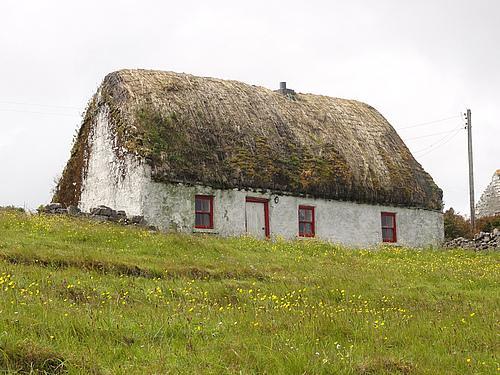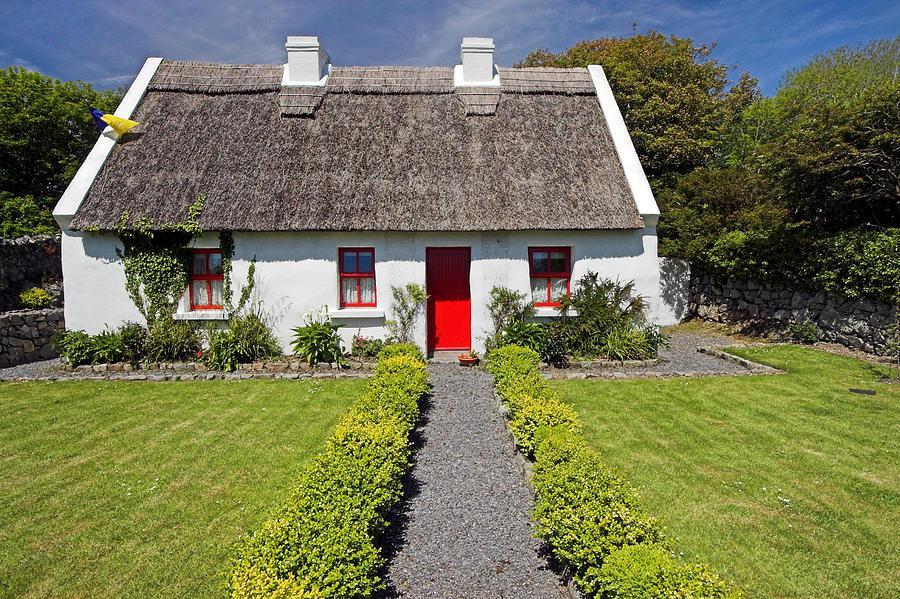The first image is the image on the left, the second image is the image on the right. For the images shown, is this caption "One of the houses has neither a red door nor red window trim." true? Answer yes or no. No. The first image is the image on the left, the second image is the image on the right. Considering the images on both sides, is "There are two windows on the left side of the door in at least one of the pictures." valid? Answer yes or no. Yes. 